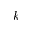Convert formula to latex. <formula><loc_0><loc_0><loc_500><loc_500>k</formula> 